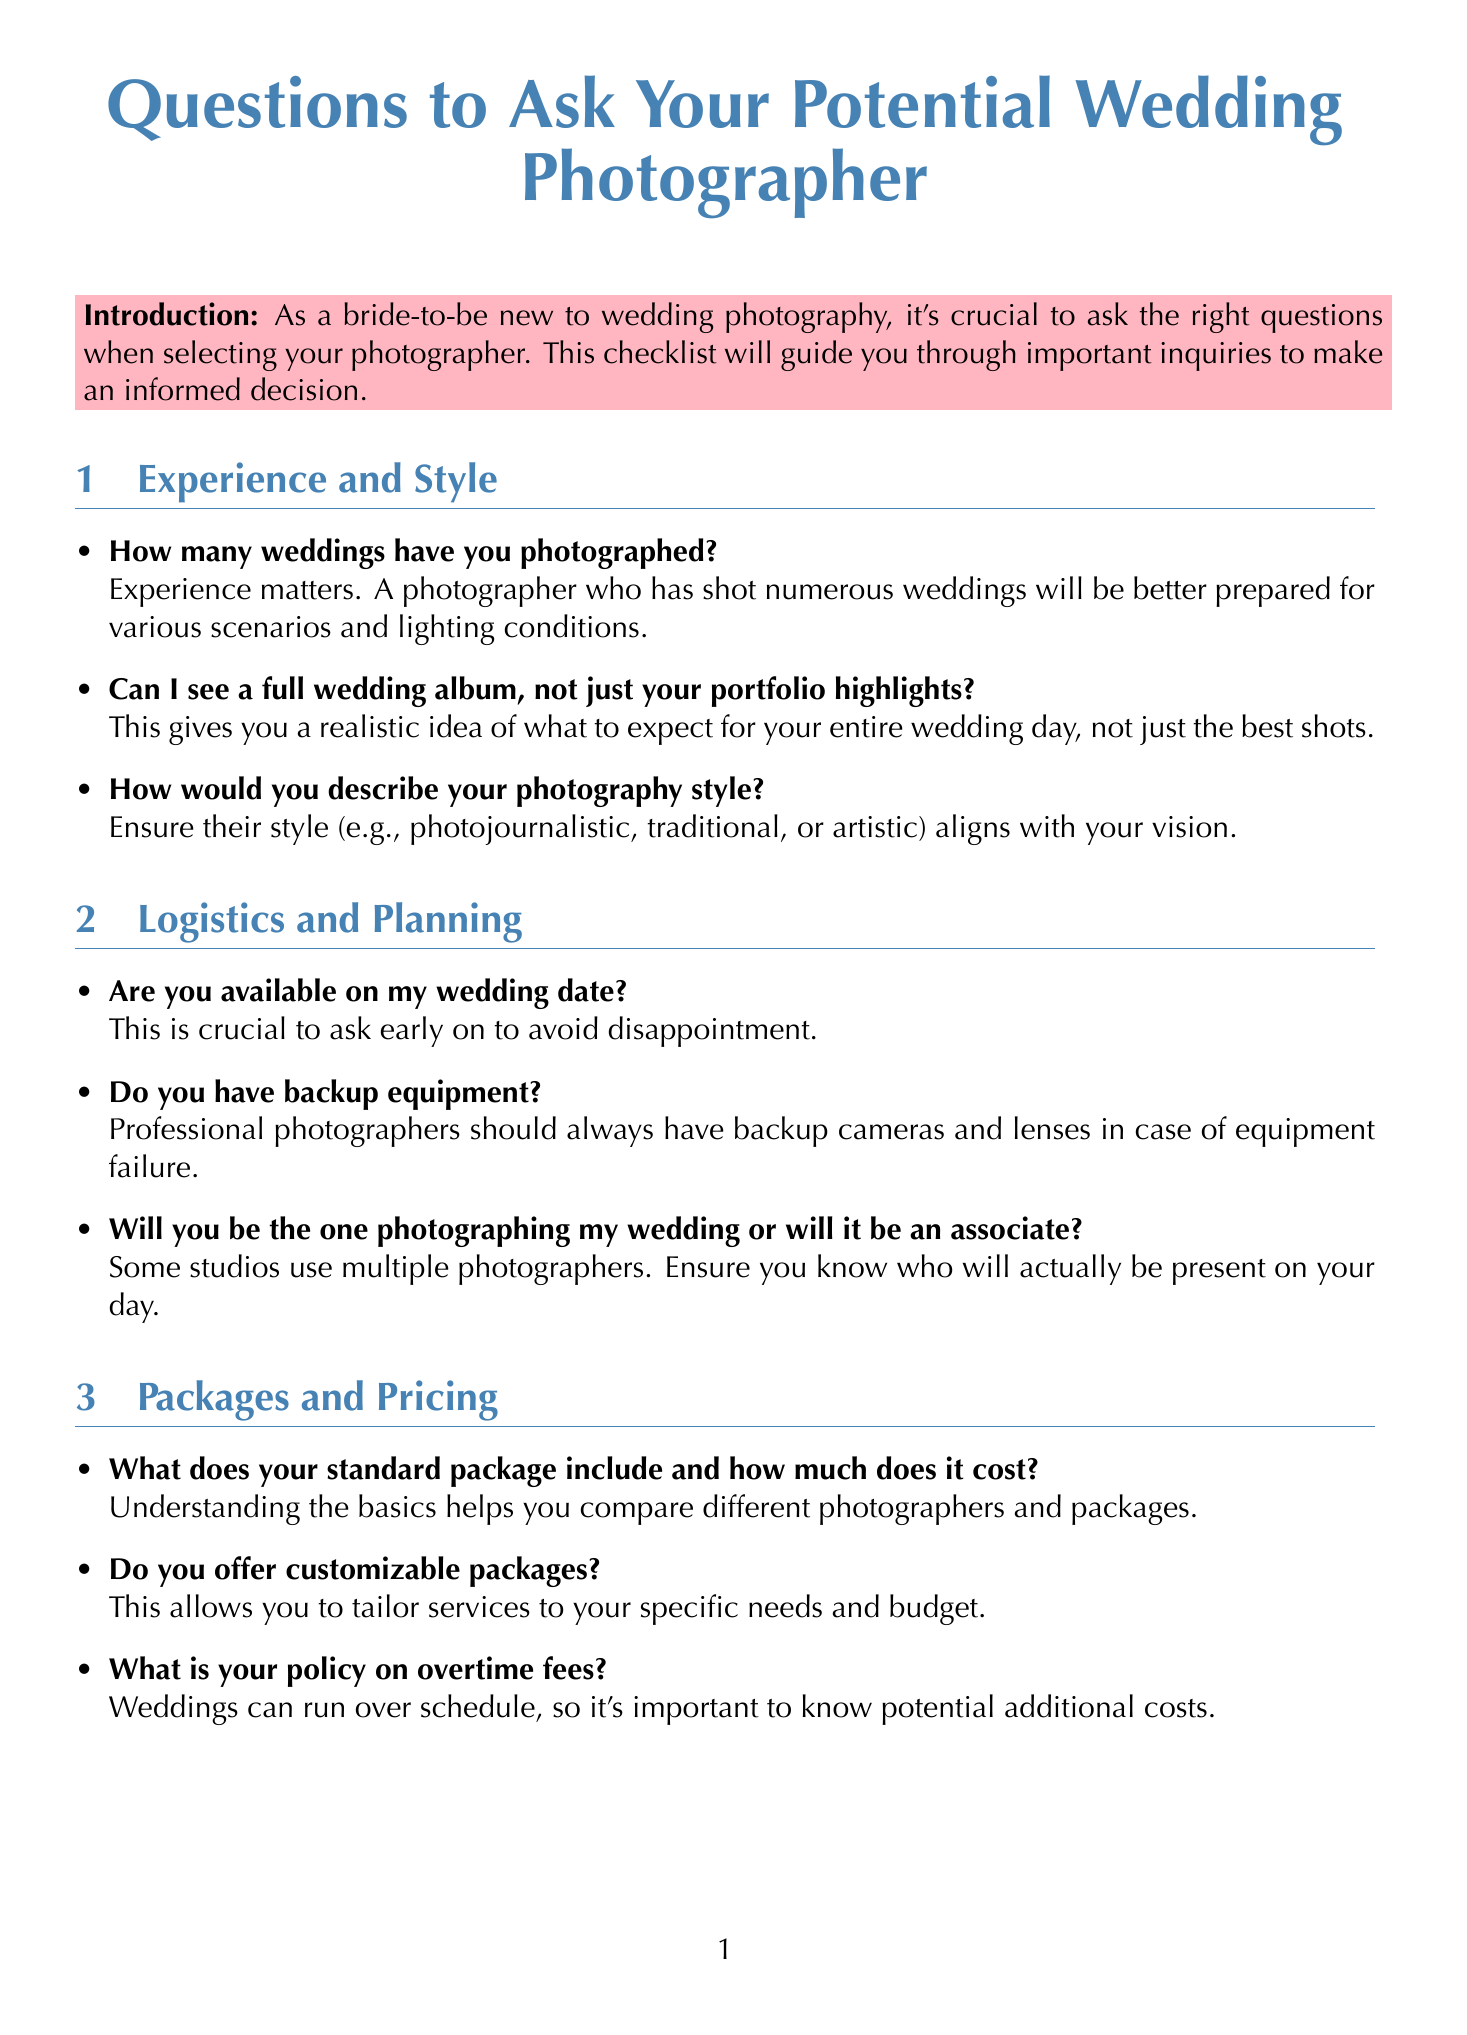How many weddings have you photographed? This question retrieves specific information related to the photographer's experience, as stated in the document.
Answer: unspecified Can I see a full wedding album? This question seeks confirmation of a service that is important for understanding the photographer's work in detail.
Answer: Full wedding album What is your policy on overtime fees? This question is crucial for understanding any additional costs that might arise during the wedding.
Answer: Overtime fees What does your standard package include? This question aims to understand what is part of the basic offering from the photographer.
Answer: Standard package How long after the wedding will we receive our photos? This question retrieves specific information about the turnaround time for photo delivery.
Answer: Varies greatly What is your cancellation policy? This question looks into the terms related to cancellation, which is important for planning.
Answer: Cancellation policy What does your contract cover? This asks for specific details on what protections the contract offers to both parties.
Answer: Contract coverage Do you offer retouching services? This question addresses the specifics of post-production services available to the client.
Answer: Retouching services Are you available on my wedding date? This is a fundamental question that needs to be answered before proceeding with any discussions.
Answer: Availability 